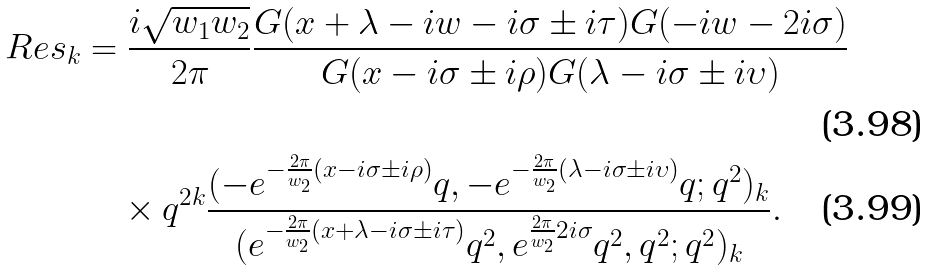<formula> <loc_0><loc_0><loc_500><loc_500>R e s _ { k } & = \frac { i \sqrt { w _ { 1 } w _ { 2 } } } { 2 \pi } \frac { G ( x + \lambda - i w - i \sigma \pm i \tau ) G ( - i w - 2 i \sigma ) } { G ( x - i \sigma \pm i \rho ) G ( \lambda - i \sigma \pm i \upsilon ) } \\ & \quad \times q ^ { 2 k } \frac { ( - e ^ { - \frac { 2 \pi } { w _ { 2 } } ( x - i \sigma \pm i \rho ) } q , - e ^ { - \frac { 2 \pi } { w _ { 2 } } ( \lambda - i \sigma \pm i \upsilon ) } q ; q ^ { 2 } ) _ { k } } { ( e ^ { - \frac { 2 \pi } { w _ { 2 } } ( x + \lambda - i \sigma \pm i \tau ) } q ^ { 2 } , e ^ { \frac { 2 \pi } { w _ { 2 } } 2 i \sigma } q ^ { 2 } , q ^ { 2 } ; q ^ { 2 } ) _ { k } } .</formula> 